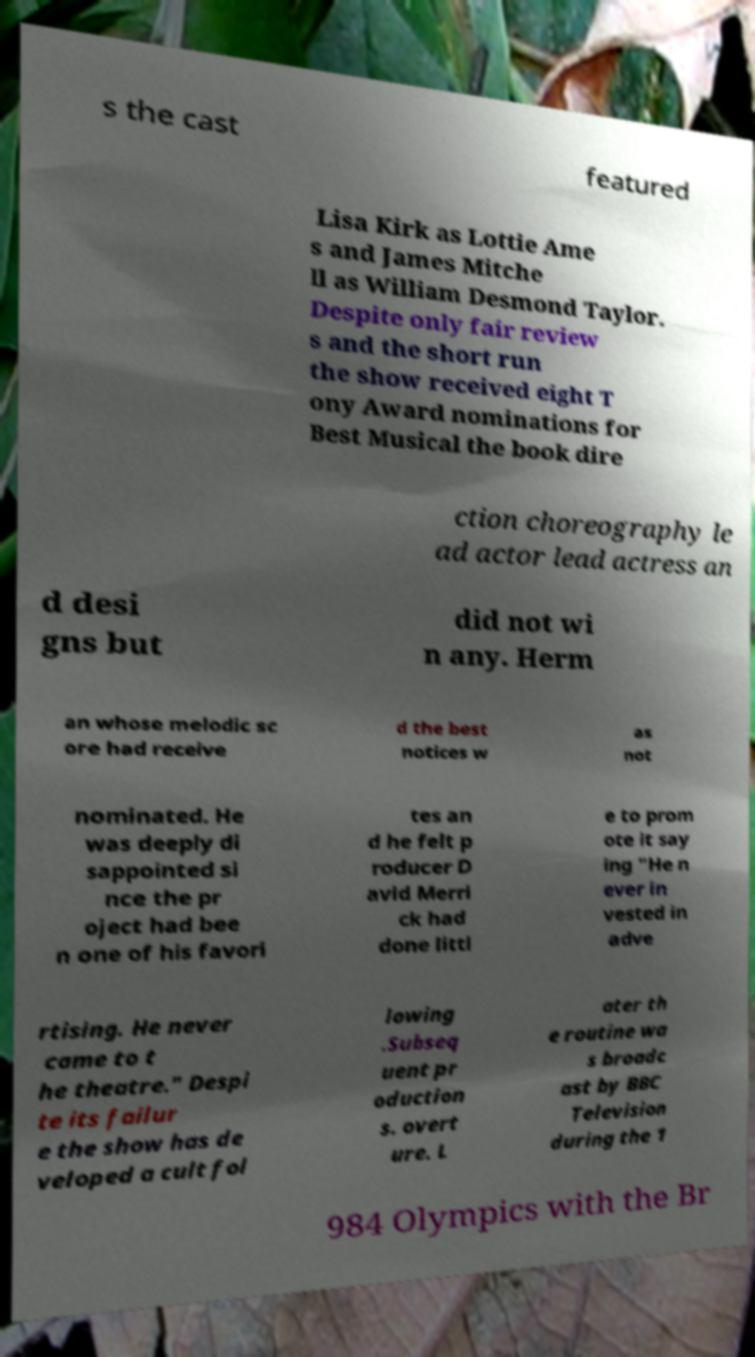Can you accurately transcribe the text from the provided image for me? s the cast featured Lisa Kirk as Lottie Ame s and James Mitche ll as William Desmond Taylor. Despite only fair review s and the short run the show received eight T ony Award nominations for Best Musical the book dire ction choreography le ad actor lead actress an d desi gns but did not wi n any. Herm an whose melodic sc ore had receive d the best notices w as not nominated. He was deeply di sappointed si nce the pr oject had bee n one of his favori tes an d he felt p roducer D avid Merri ck had done littl e to prom ote it say ing "He n ever in vested in adve rtising. He never came to t he theatre." Despi te its failur e the show has de veloped a cult fol lowing .Subseq uent pr oduction s. overt ure. L ater th e routine wa s broadc ast by BBC Television during the 1 984 Olympics with the Br 